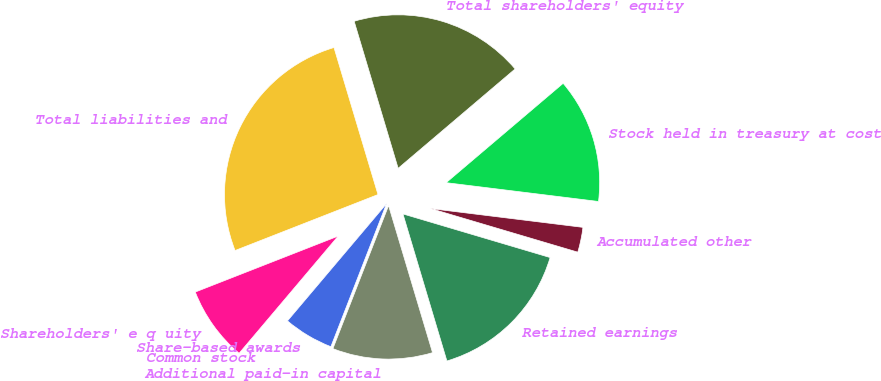Convert chart. <chart><loc_0><loc_0><loc_500><loc_500><pie_chart><fcel>Shareholders' e q uity<fcel>Common stock<fcel>Share-based awards<fcel>Additional paid-in capital<fcel>Retained earnings<fcel>Accumulated other<fcel>Stock held in treasury at cost<fcel>Total shareholders' equity<fcel>Total liabilities and<nl><fcel>7.89%<fcel>0.0%<fcel>5.26%<fcel>10.53%<fcel>15.79%<fcel>2.63%<fcel>13.16%<fcel>18.42%<fcel>26.31%<nl></chart> 